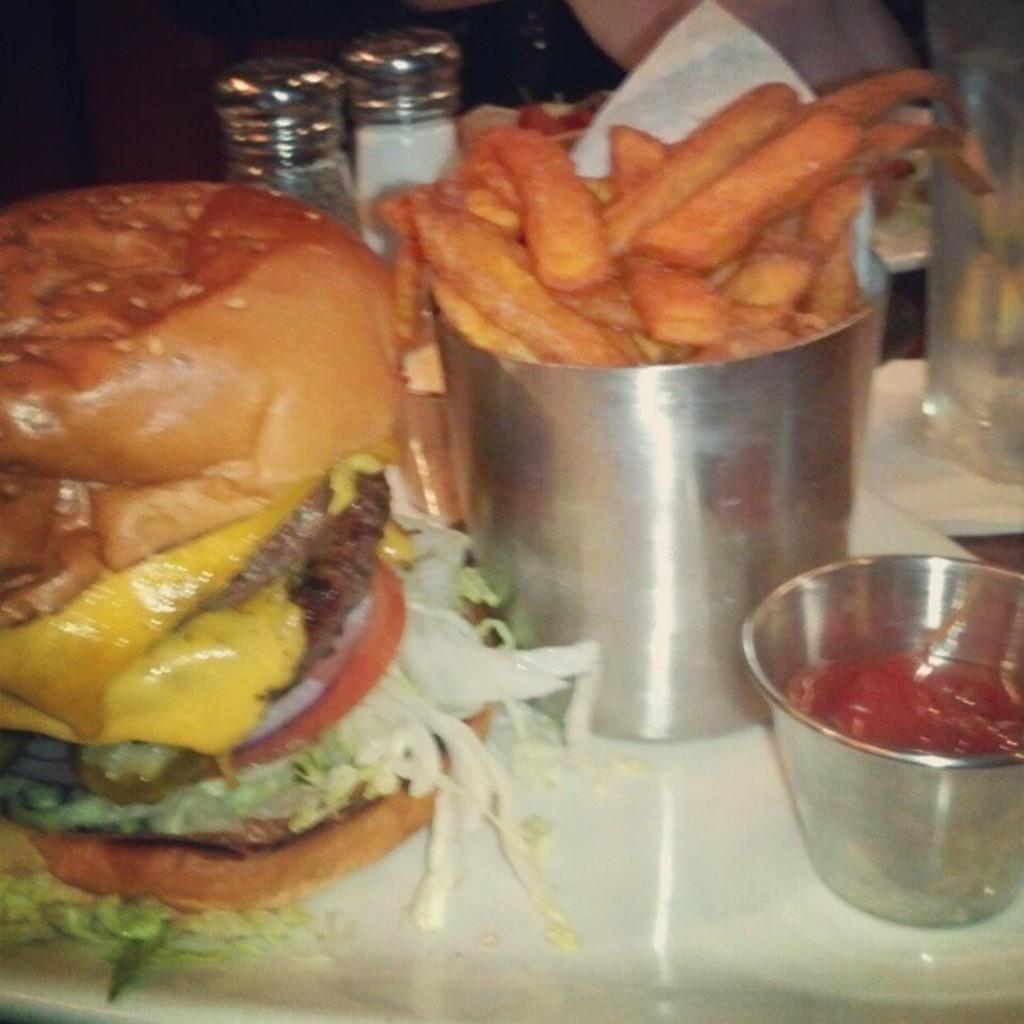What type of food is the main subject of the image? There is a burger in the image. What other food items can be seen in the image? There are bowls with sauce and food items in the image. What type of containers are present in the image? There are containers in the image. What is the liquid in the glass? The glass contains liquid, but the specific type of liquid is not mentioned in the facts. What color is the surface the items are placed on? The surface the items are placed on is white. What part of a person is visible in the image? The top of a human body is visible in the image. What year is depicted in the image? The facts provided do not mention any specific year or time period, so it is not possible to determine the year from the image. 